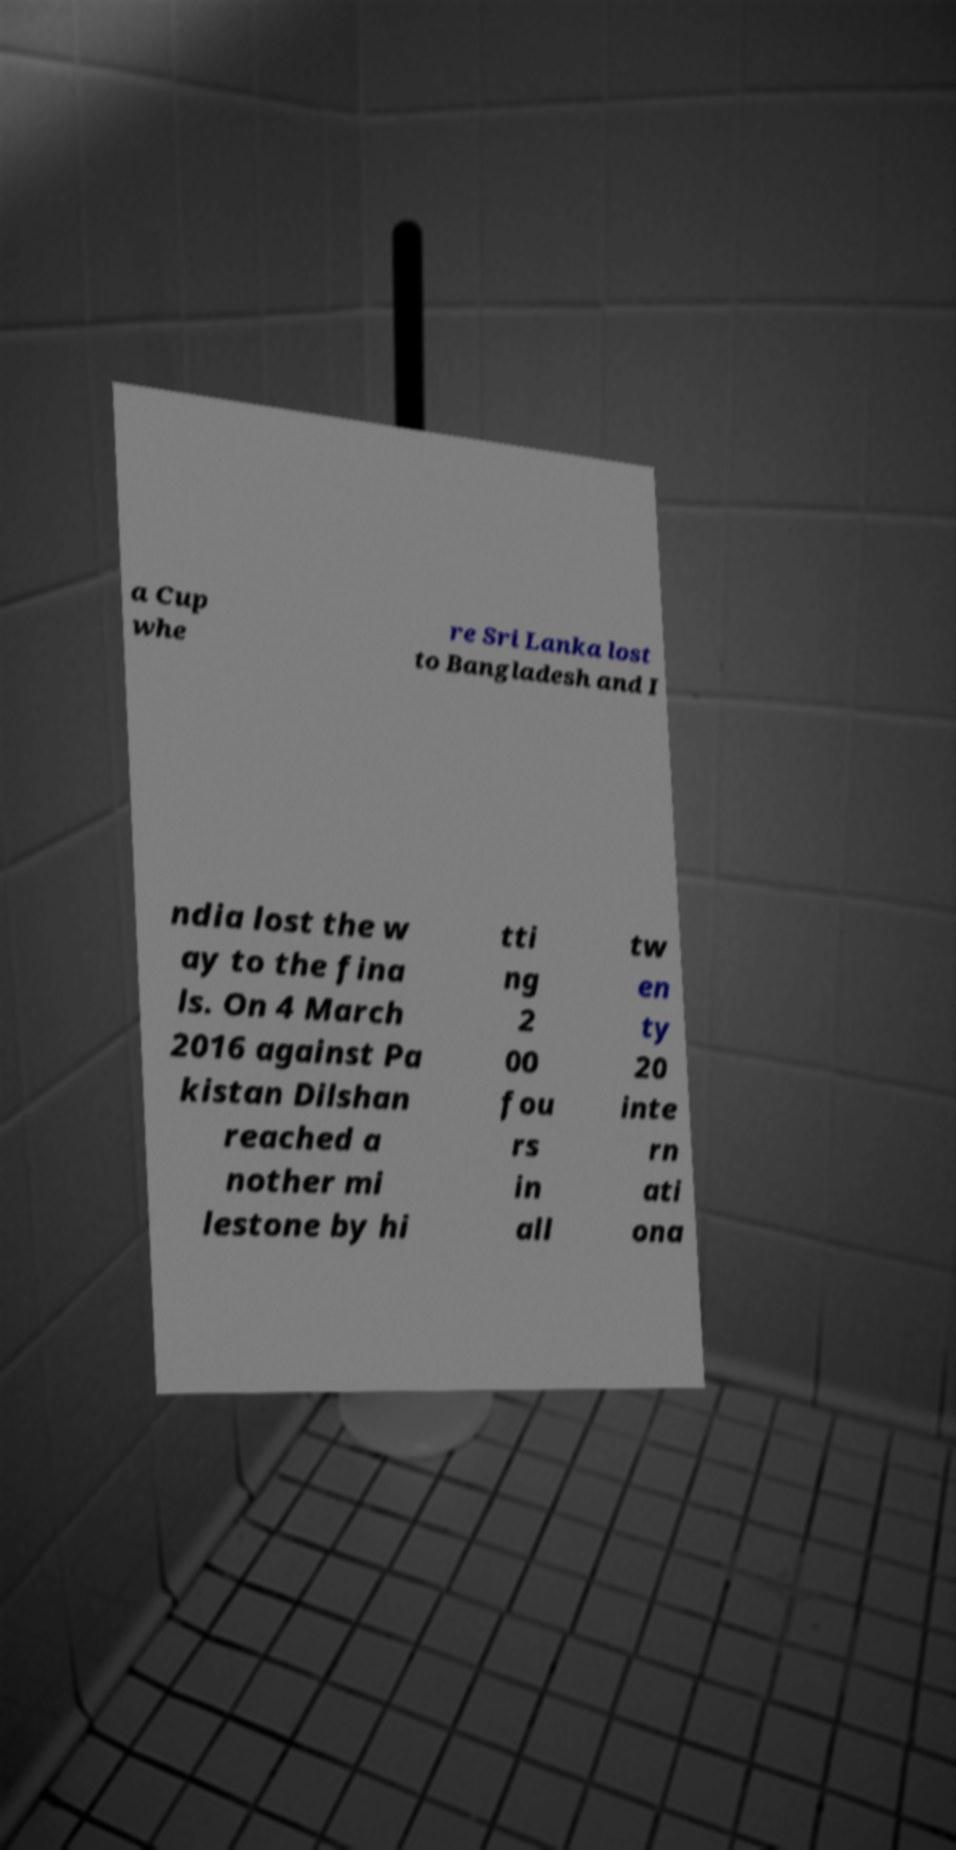I need the written content from this picture converted into text. Can you do that? a Cup whe re Sri Lanka lost to Bangladesh and I ndia lost the w ay to the fina ls. On 4 March 2016 against Pa kistan Dilshan reached a nother mi lestone by hi tti ng 2 00 fou rs in all tw en ty 20 inte rn ati ona 